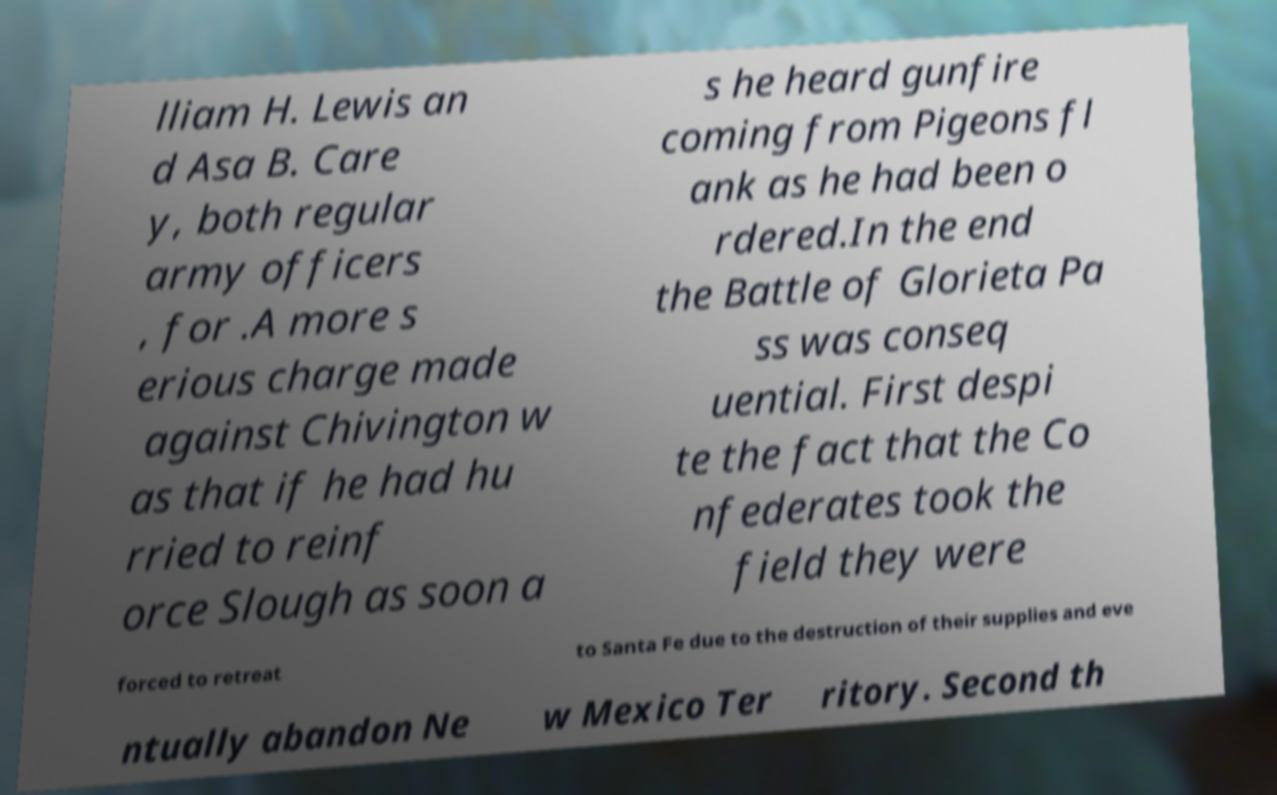Could you extract and type out the text from this image? lliam H. Lewis an d Asa B. Care y, both regular army officers , for .A more s erious charge made against Chivington w as that if he had hu rried to reinf orce Slough as soon a s he heard gunfire coming from Pigeons fl ank as he had been o rdered.In the end the Battle of Glorieta Pa ss was conseq uential. First despi te the fact that the Co nfederates took the field they were forced to retreat to Santa Fe due to the destruction of their supplies and eve ntually abandon Ne w Mexico Ter ritory. Second th 